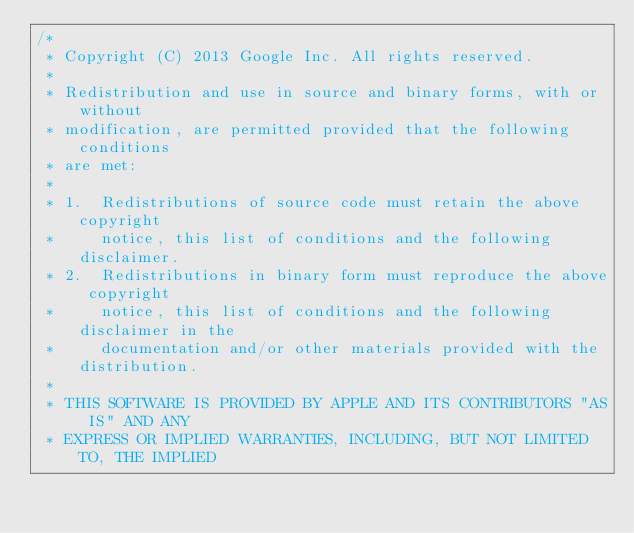<code> <loc_0><loc_0><loc_500><loc_500><_C++_>/*
 * Copyright (C) 2013 Google Inc. All rights reserved.
 *
 * Redistribution and use in source and binary forms, with or without
 * modification, are permitted provided that the following conditions
 * are met:
 *
 * 1.  Redistributions of source code must retain the above copyright
 *     notice, this list of conditions and the following disclaimer.
 * 2.  Redistributions in binary form must reproduce the above copyright
 *     notice, this list of conditions and the following disclaimer in the
 *     documentation and/or other materials provided with the distribution.
 *
 * THIS SOFTWARE IS PROVIDED BY APPLE AND ITS CONTRIBUTORS "AS IS" AND ANY
 * EXPRESS OR IMPLIED WARRANTIES, INCLUDING, BUT NOT LIMITED TO, THE IMPLIED</code> 